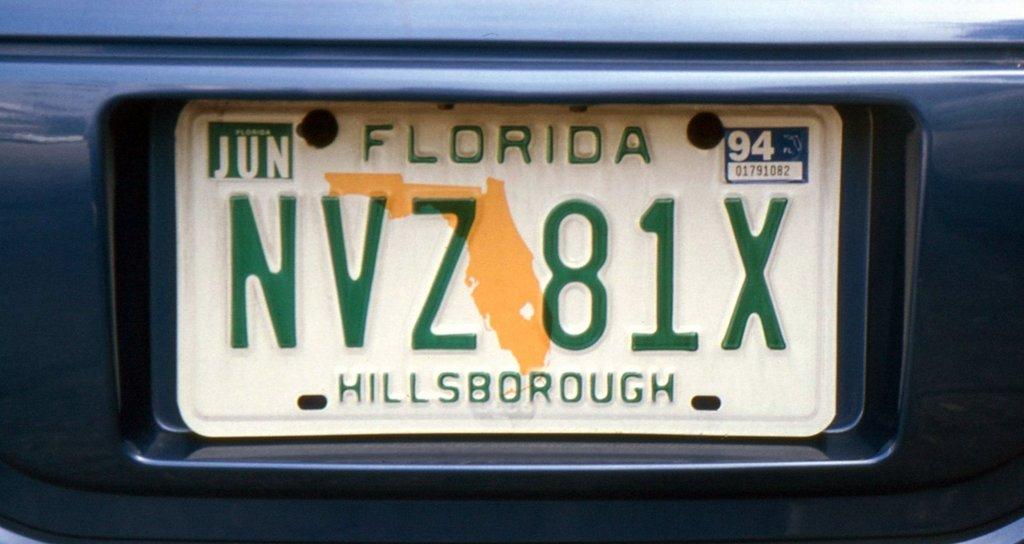What state is the plate from ?
Keep it short and to the point. Florida. What county is the plate from?
Offer a terse response. Hillsborough. 